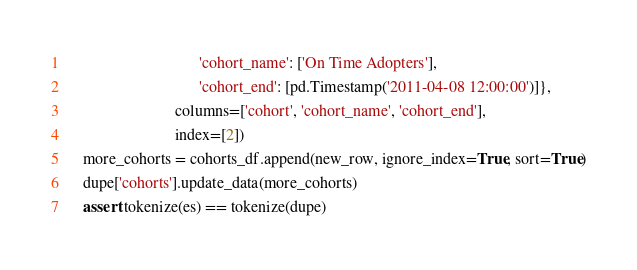<code> <loc_0><loc_0><loc_500><loc_500><_Python_>                                 'cohort_name': ['On Time Adopters'],
                                 'cohort_end': [pd.Timestamp('2011-04-08 12:00:00')]},
                           columns=['cohort', 'cohort_name', 'cohort_end'],
                           index=[2])
    more_cohorts = cohorts_df.append(new_row, ignore_index=True, sort=True)
    dupe['cohorts'].update_data(more_cohorts)
    assert tokenize(es) == tokenize(dupe)
</code> 